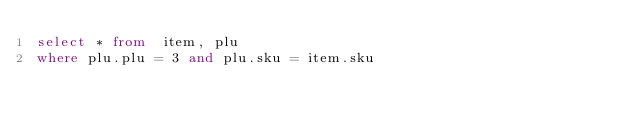<code> <loc_0><loc_0><loc_500><loc_500><_SQL_>select * from  item, plu
where plu.plu = 3 and plu.sku = item.sku
</code> 